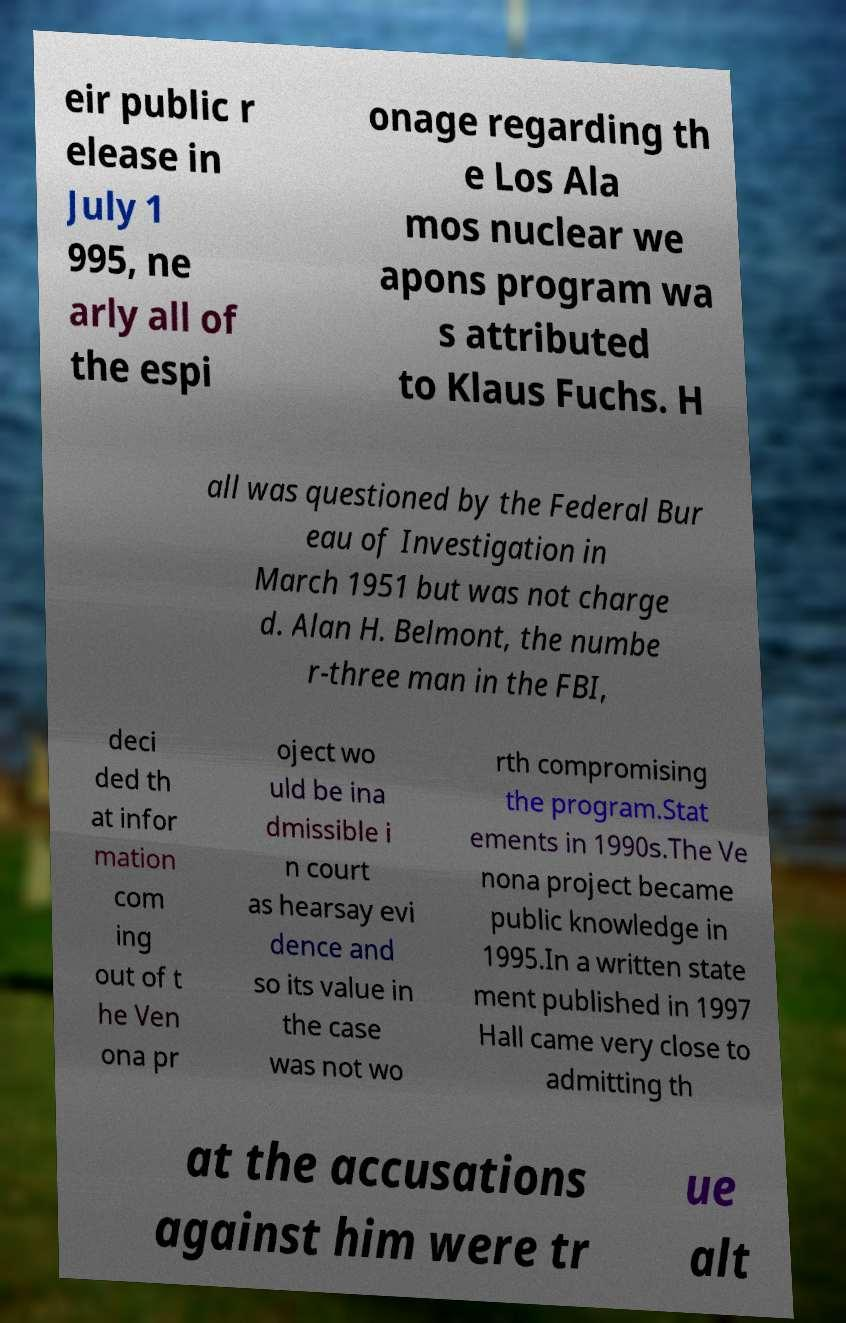For documentation purposes, I need the text within this image transcribed. Could you provide that? eir public r elease in July 1 995, ne arly all of the espi onage regarding th e Los Ala mos nuclear we apons program wa s attributed to Klaus Fuchs. H all was questioned by the Federal Bur eau of Investigation in March 1951 but was not charge d. Alan H. Belmont, the numbe r-three man in the FBI, deci ded th at infor mation com ing out of t he Ven ona pr oject wo uld be ina dmissible i n court as hearsay evi dence and so its value in the case was not wo rth compromising the program.Stat ements in 1990s.The Ve nona project became public knowledge in 1995.In a written state ment published in 1997 Hall came very close to admitting th at the accusations against him were tr ue alt 